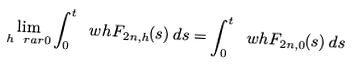Convert formula to latex. <formula><loc_0><loc_0><loc_500><loc_500>\lim _ { h \ r a r 0 } \int _ { 0 } ^ { t } \ w h { F } _ { 2 n , h } ( s ) \, d s = \int _ { 0 } ^ { t } \ w h { F } _ { 2 n , 0 } ( s ) \, d s</formula> 